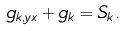<formula> <loc_0><loc_0><loc_500><loc_500>g _ { k , y x } + g _ { k } = S _ { k } .</formula> 